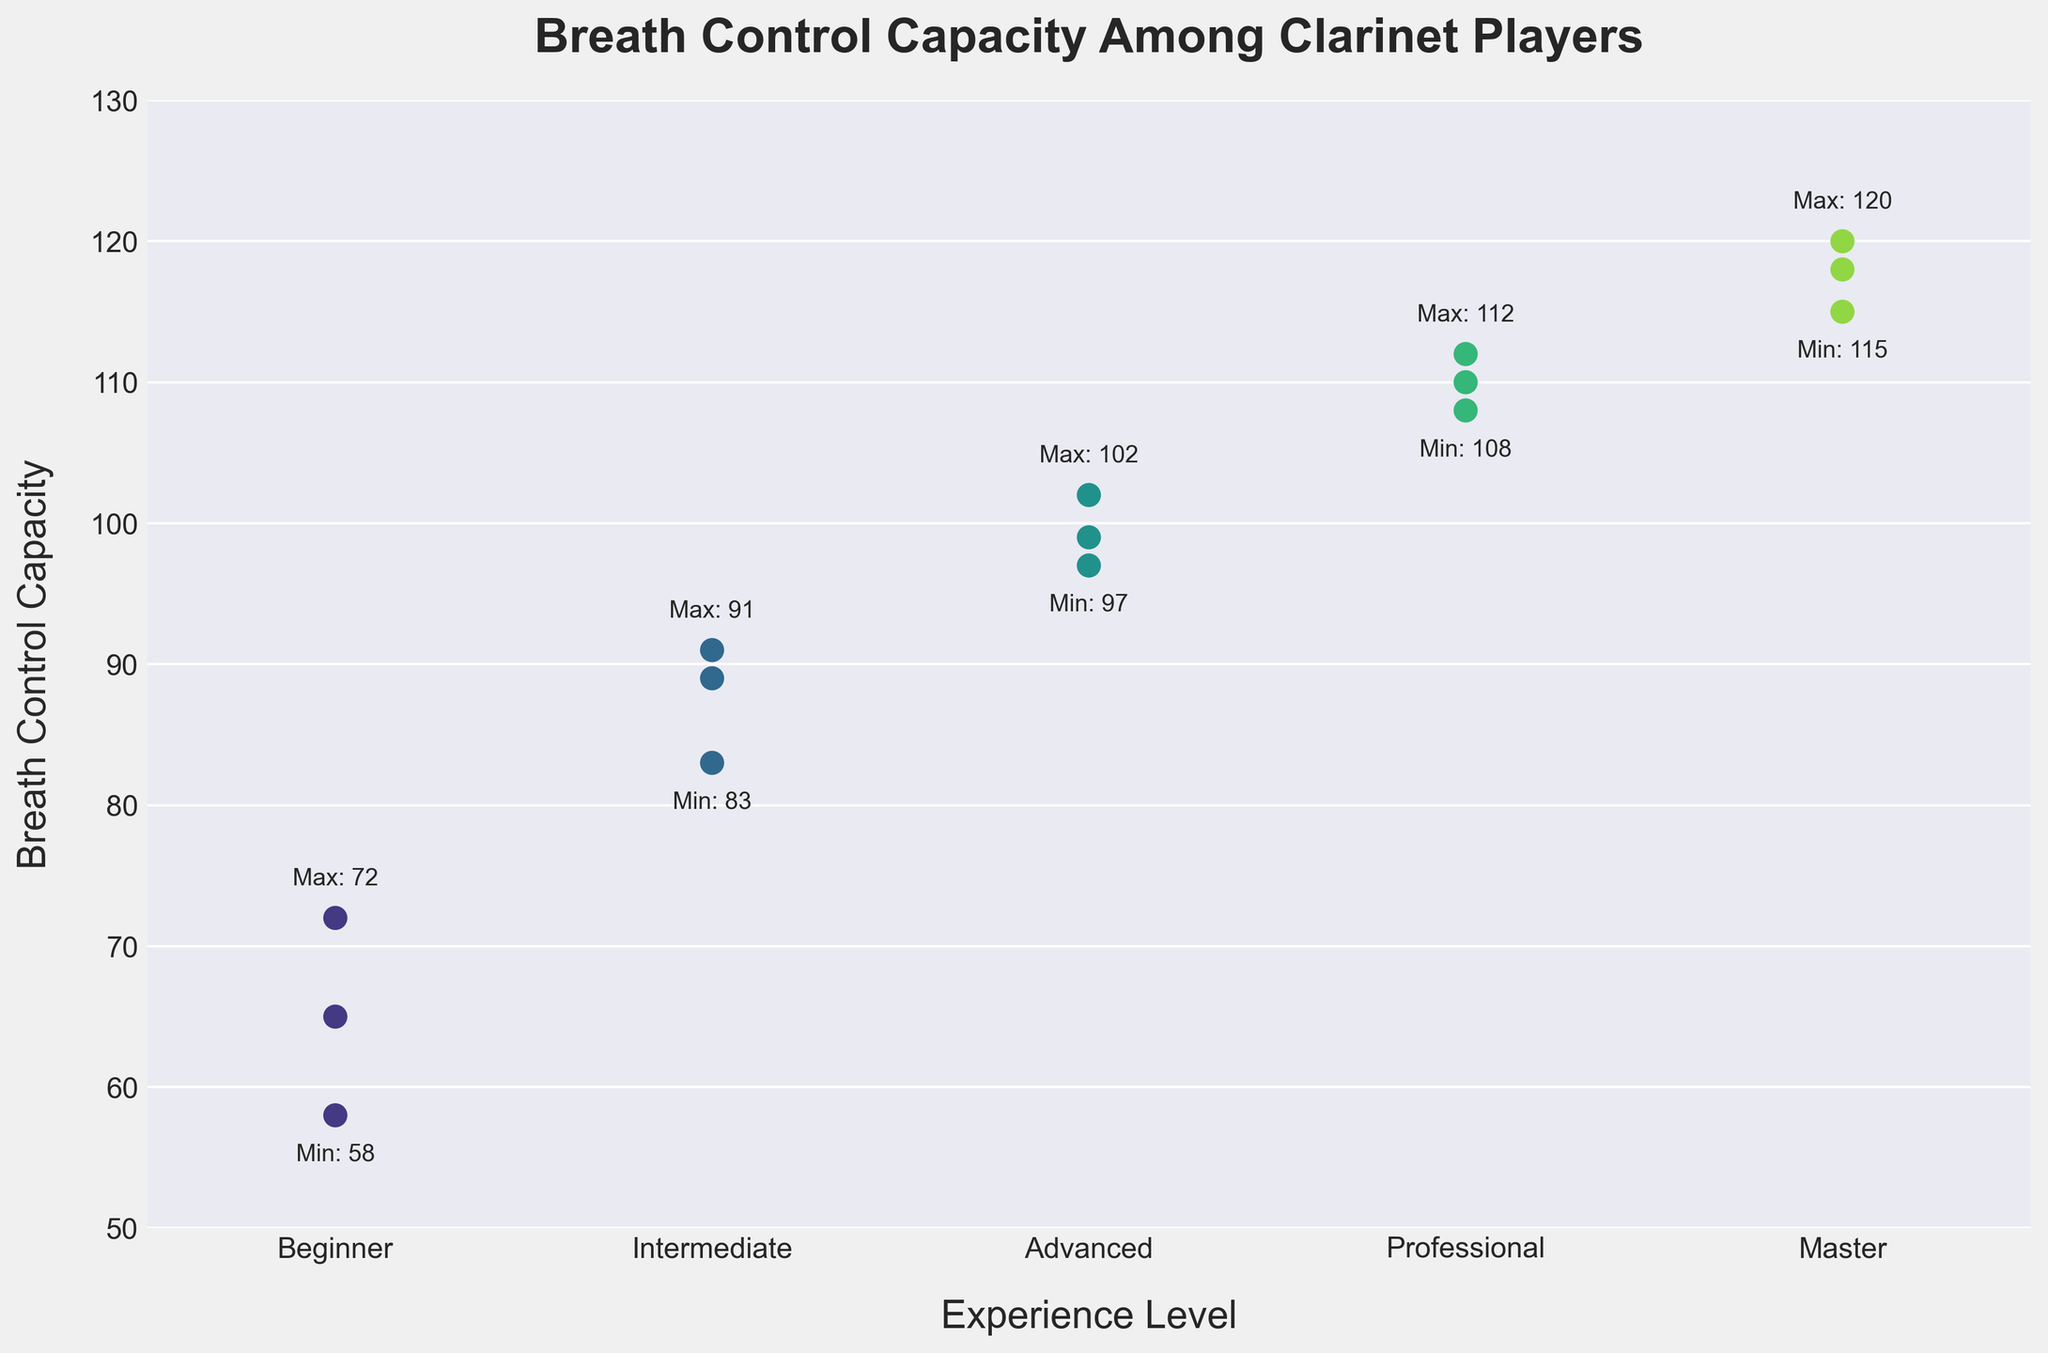What is the title of the plot? The title is located at the top center of the plot. It reads "Breath Control Capacity Among Clarinet Players."
Answer: Breath Control Capacity Among Clarinet Players Which experience level shows the highest breath control capacity? The master level has the highest breath control capacity, with a maximum value of 120, as indicated by the "Max: 120" label above the highest point in that category.
Answer: Master How many experience levels are represented in the plot? The experience levels are marked on the x-axis. There are five categories: "Beginner," "Intermediate," "Advanced," "Professional," and "Master."
Answer: Five In which experience level category is the lowest breath control capacity observed? The lowest breath control capacity is shown in the "Beginner" category, with a value of 58, as indicated by the "Min: 58" label near the lowest point in that category.
Answer: Beginner What is the difference between the maximum breath control capacity of the Professional and Advanced levels? The maximum value for the Professional level is 112, and for the Advanced level, it is 102. The difference between these capacities is 112 - 102 = 10.
Answer: 10 What is the range of breath control capacities among Intermediate players? In the Intermediate category, the minimum value is 83, and the maximum value is 91. The range is calculated as 91 - 83 = 8.
Answer: 8 Compare the median breath control capacity between Intermediate and Advanced levels. Which one is higher? To find the median, list the values in ascending order for both groups. For Intermediate: 83, 89, 91 (median is 89). For Advanced: 97, 99, 102 (median is 99). Thus, the Advanced level has a higher median breath control capacity.
Answer: Advanced How many data points are there for each experience level? Count the dots within each category on the x-axis. There are 3 players in each of the experience level categories: Beginner, Intermediate, Advanced, Professional, and Master.
Answer: Three per category What is the average breath control capacity for Master players? The breath control capacities for Master players are 118, 115, and 120. Adding them gives 118 + 115 + 120 = 353, and the average is 353 / 3 ≈ 117.67.
Answer: 117.67 Which experience level has the smallest spread in breath control capacities? To determine the spread, look for the difference between the maximum and minimum values for each category. The Advanced level has values from 97 to 102, giving a spread of 102 - 97 = 5, which is the smallest among the categories.
Answer: Advanced 